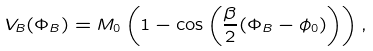<formula> <loc_0><loc_0><loc_500><loc_500>V _ { B } ( \Phi _ { B } ) = M _ { 0 } \left ( 1 - \cos \left ( \frac { \beta } { 2 } ( \Phi _ { B } - \phi _ { 0 } ) \right ) \right ) ,</formula> 